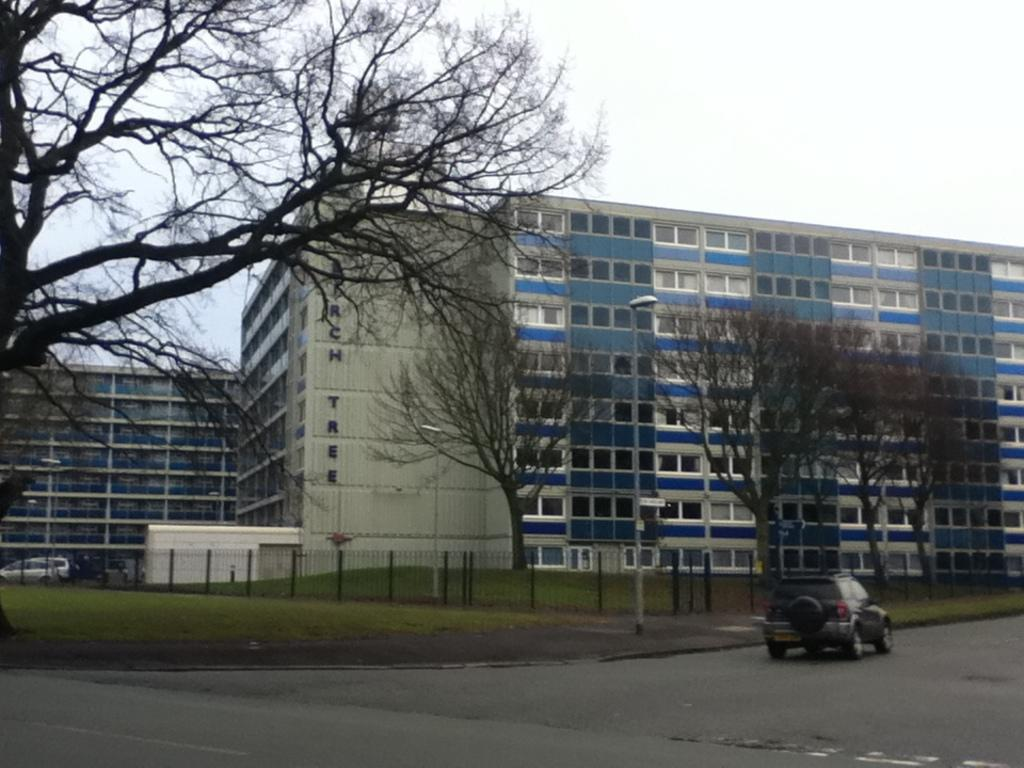What can be seen on the road in the image? There are cars parked on the road in the image. What type of surface covers the ground in the image? The ground is covered with grass in the image. What type of vegetation is present in the image? There are trees in the image. What type of structures can be seen in the image? There are buildings in the image. What is the condition of the sky in the image? The sky is clear in the image. Where is the map located in the image? There is no map present in the image. What type of soil can be seen in the image? The ground is covered with grass, not dirt, in the image. Which direction is the image facing? The image does not indicate a specific direction, such as north. 